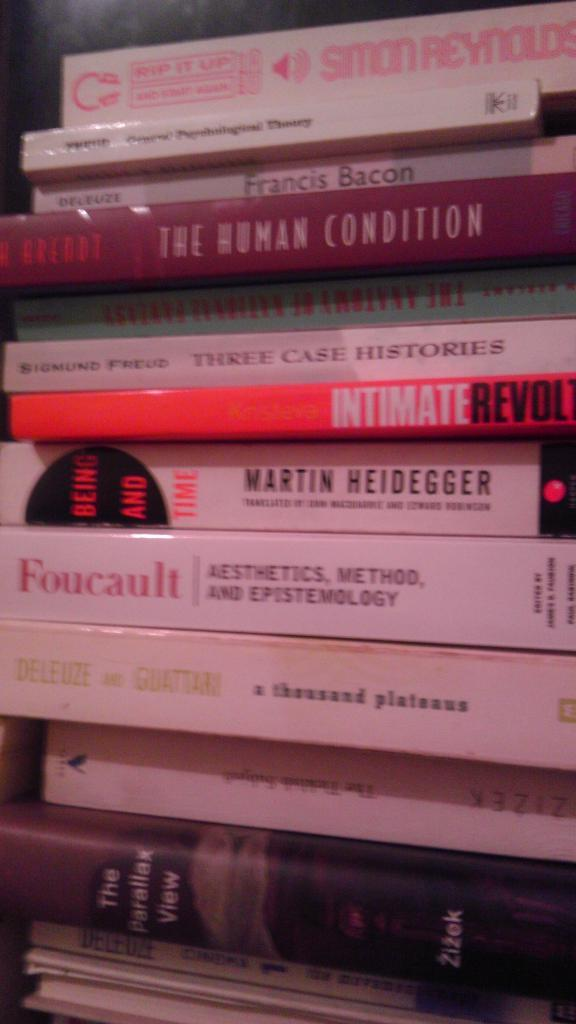<image>
Relay a brief, clear account of the picture shown. A bunch of books stacked on top of each other, one of which is titled intimate revolt. 